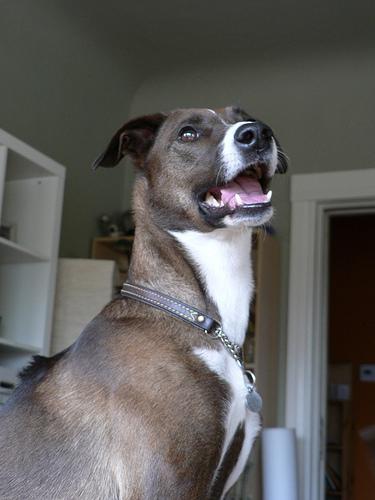Is this dog barking?
Write a very short answer. No. Is the dog looking down?
Quick response, please. No. What color is the dog?
Concise answer only. Brown and white. Is the dog sad?
Give a very brief answer. No. 